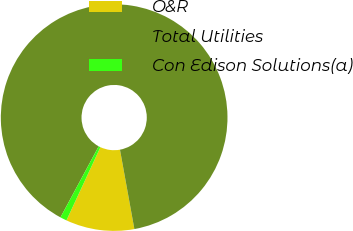Convert chart to OTSL. <chart><loc_0><loc_0><loc_500><loc_500><pie_chart><fcel>O&R<fcel>Total Utilities<fcel>Con Edison Solutions(a)<nl><fcel>9.77%<fcel>89.29%<fcel>0.94%<nl></chart> 